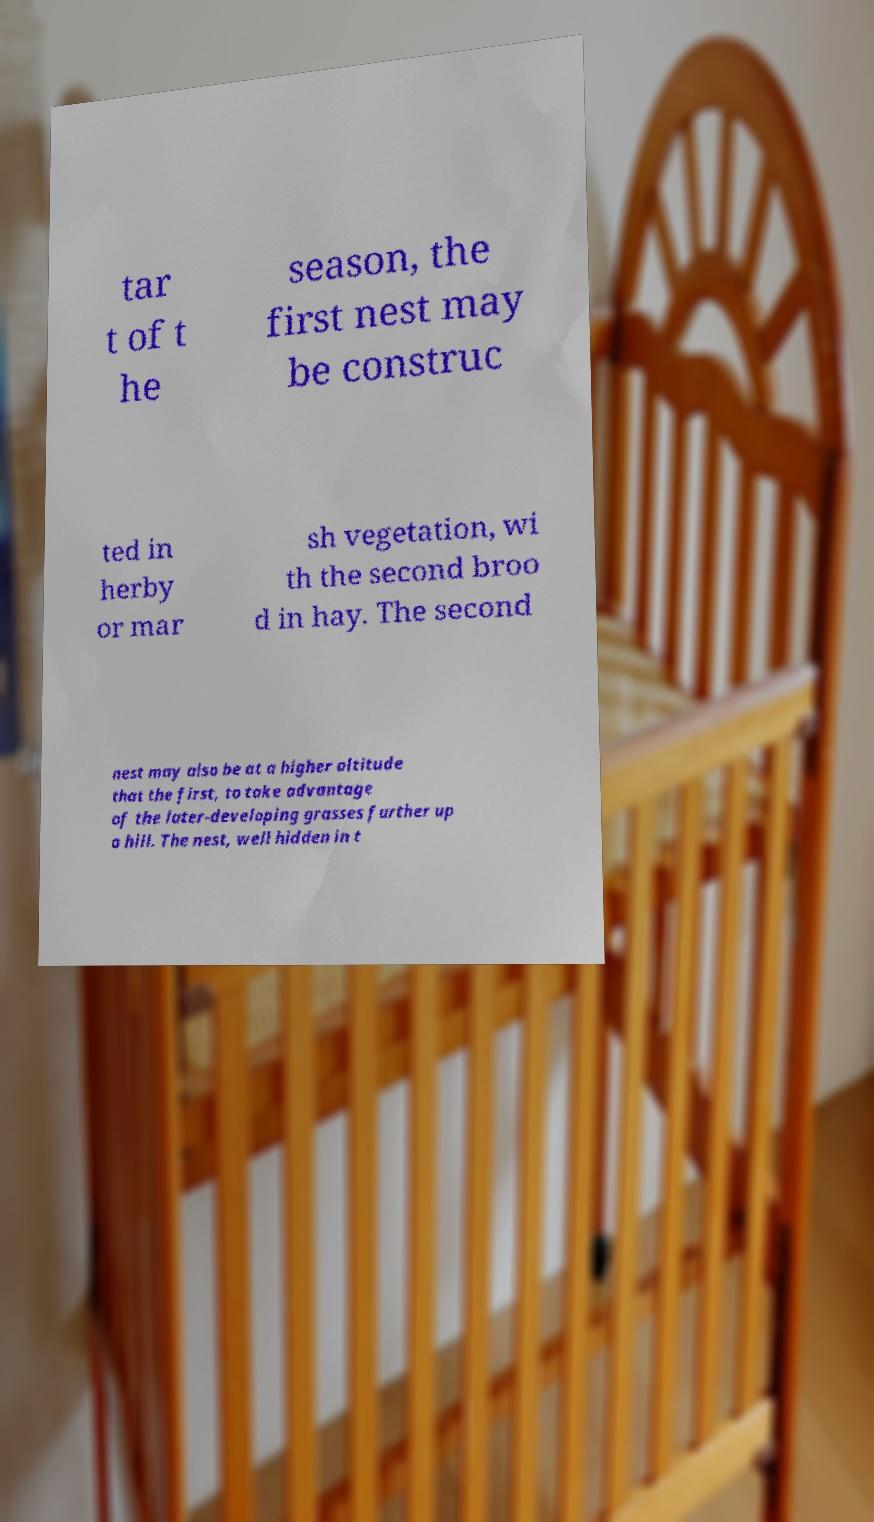Can you read and provide the text displayed in the image?This photo seems to have some interesting text. Can you extract and type it out for me? tar t of t he season, the first nest may be construc ted in herby or mar sh vegetation, wi th the second broo d in hay. The second nest may also be at a higher altitude that the first, to take advantage of the later-developing grasses further up a hill. The nest, well hidden in t 